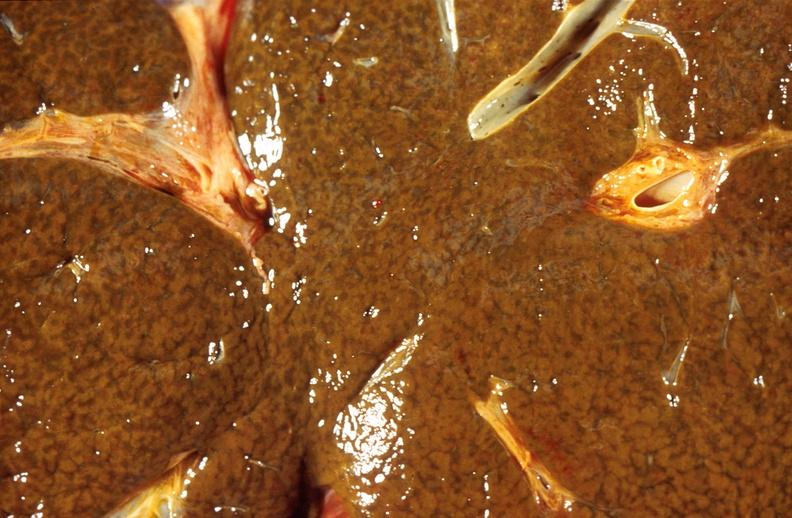does acute peritonitis show liver, cholestasis and cirrhosis in a patient with cystic fibrosis?
Answer the question using a single word or phrase. No 